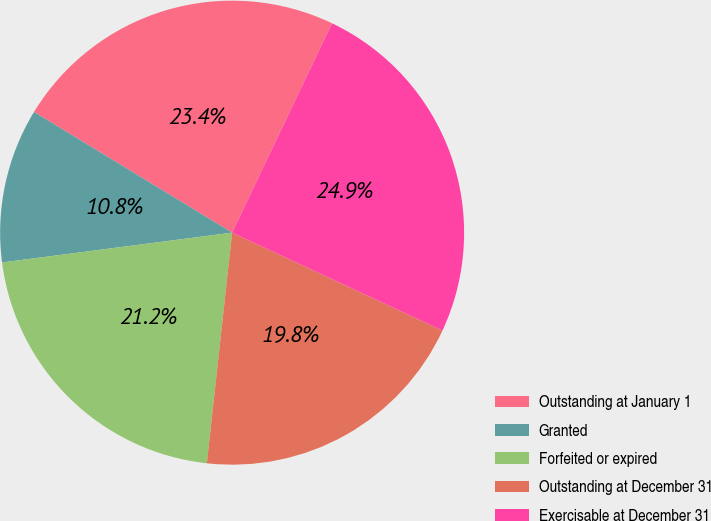Convert chart. <chart><loc_0><loc_0><loc_500><loc_500><pie_chart><fcel>Outstanding at January 1<fcel>Granted<fcel>Forfeited or expired<fcel>Outstanding at December 31<fcel>Exercisable at December 31<nl><fcel>23.37%<fcel>10.76%<fcel>21.21%<fcel>19.8%<fcel>24.85%<nl></chart> 